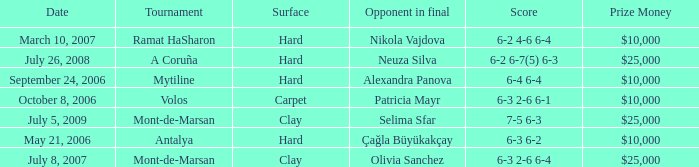What is the surface of the match on July 5, 2009? Clay. 